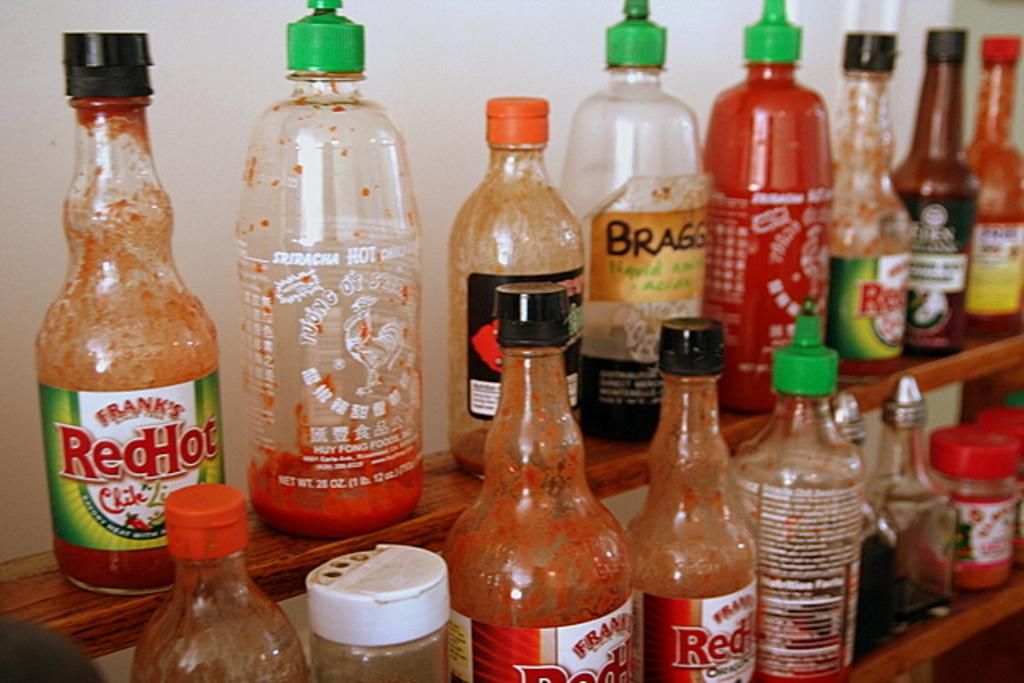<image>
Give a short and clear explanation of the subsequent image. Several bottles of hot sauce, including Frank's Red Hot, are on display. 